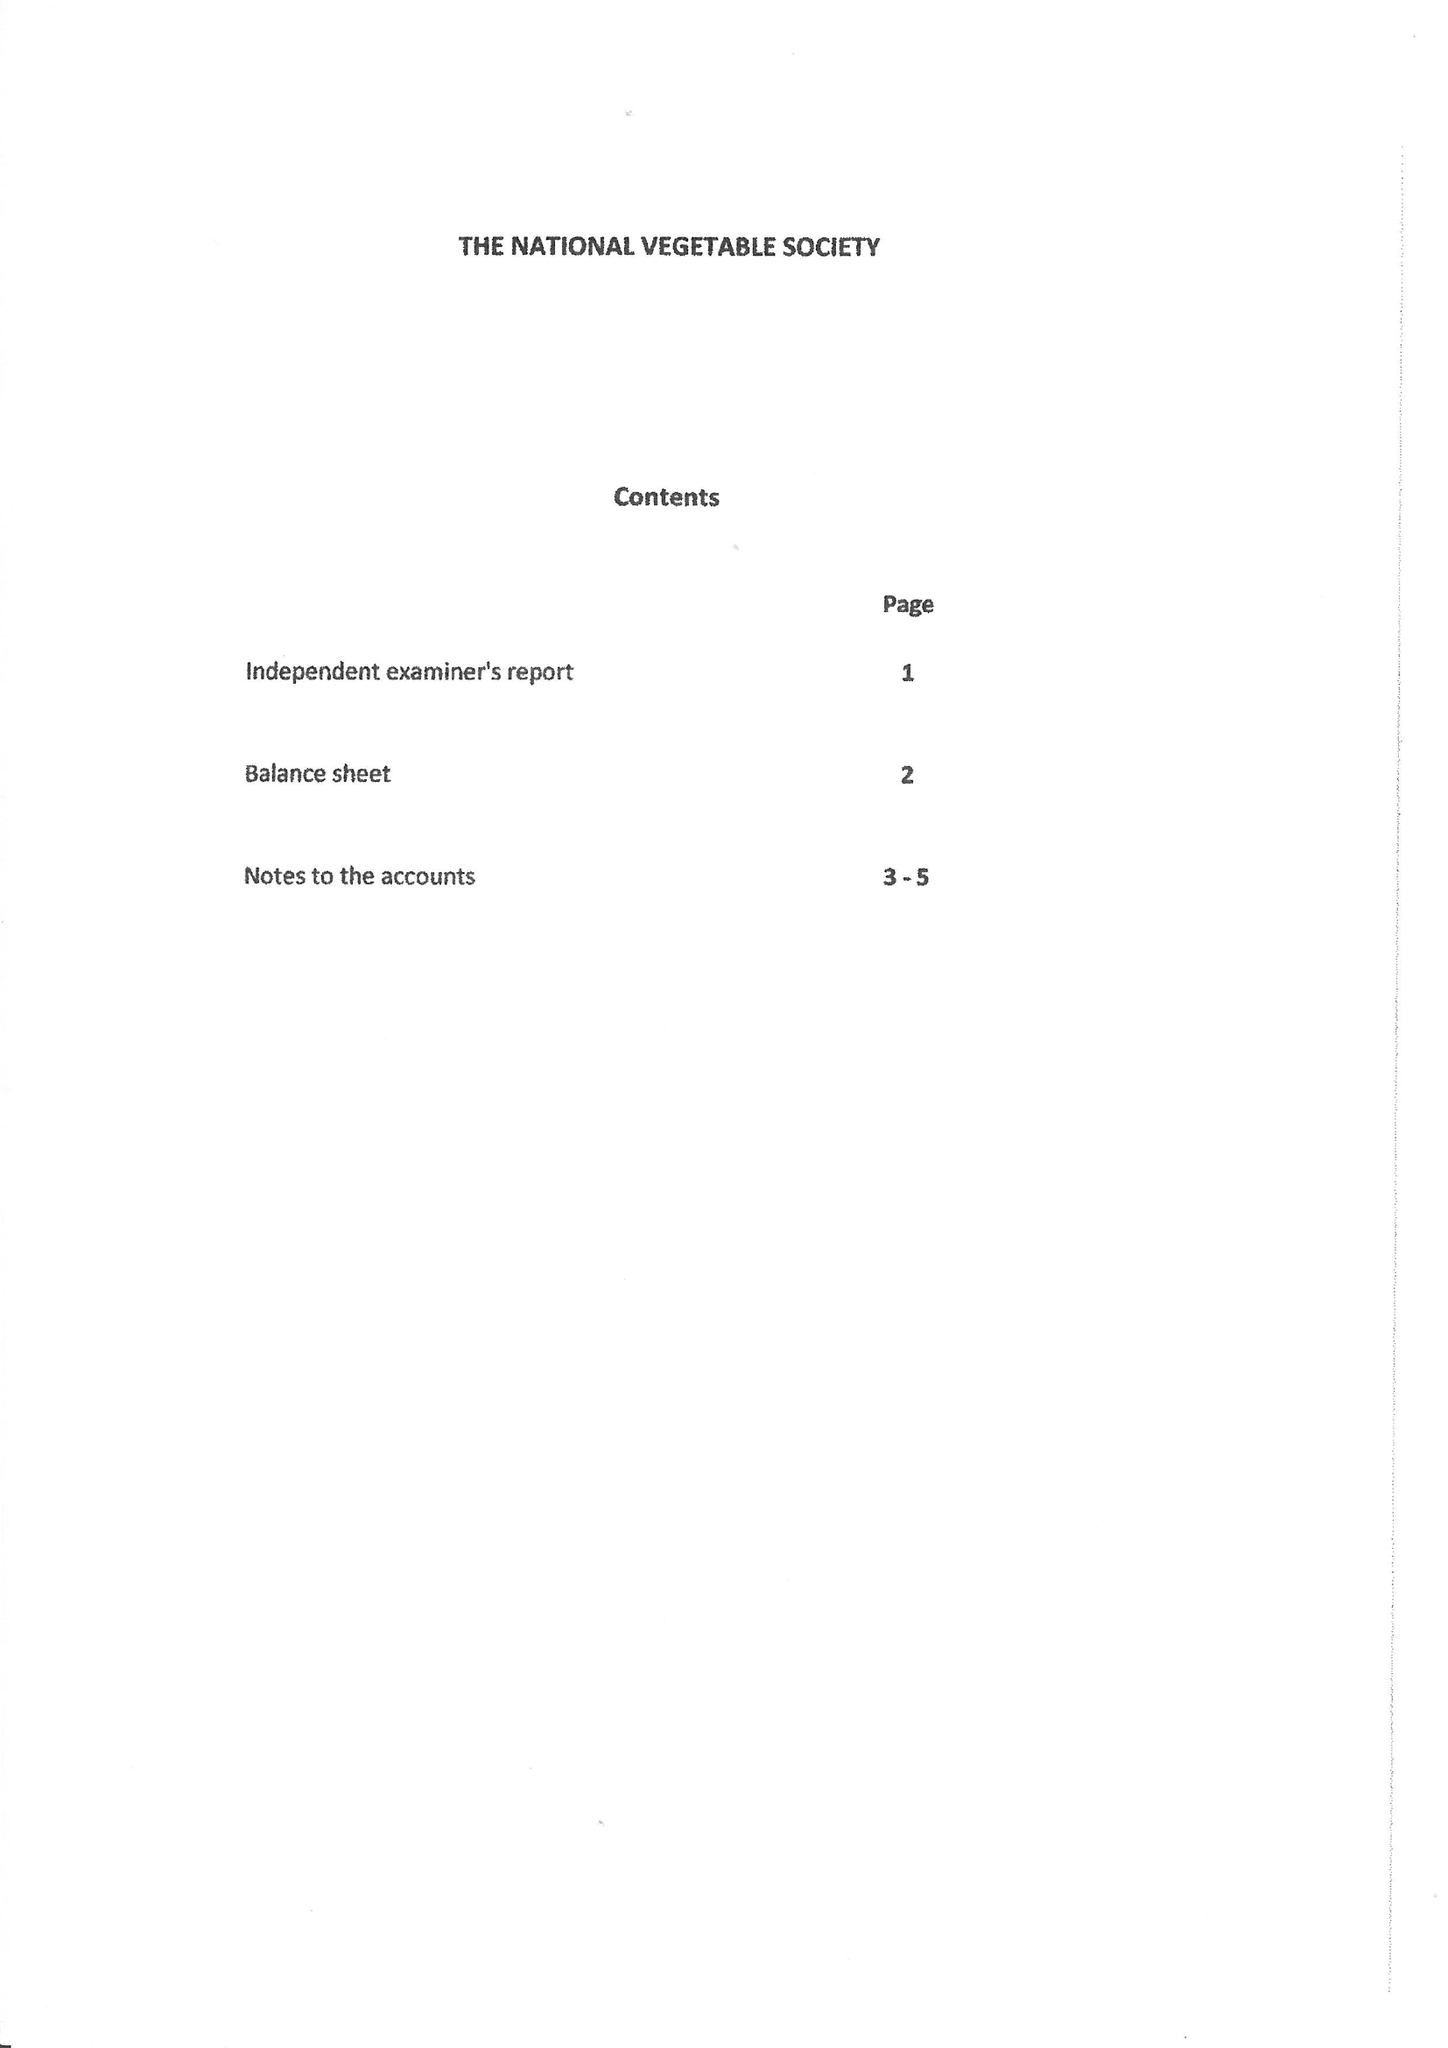What is the value for the spending_annually_in_british_pounds?
Answer the question using a single word or phrase. 118648.00 